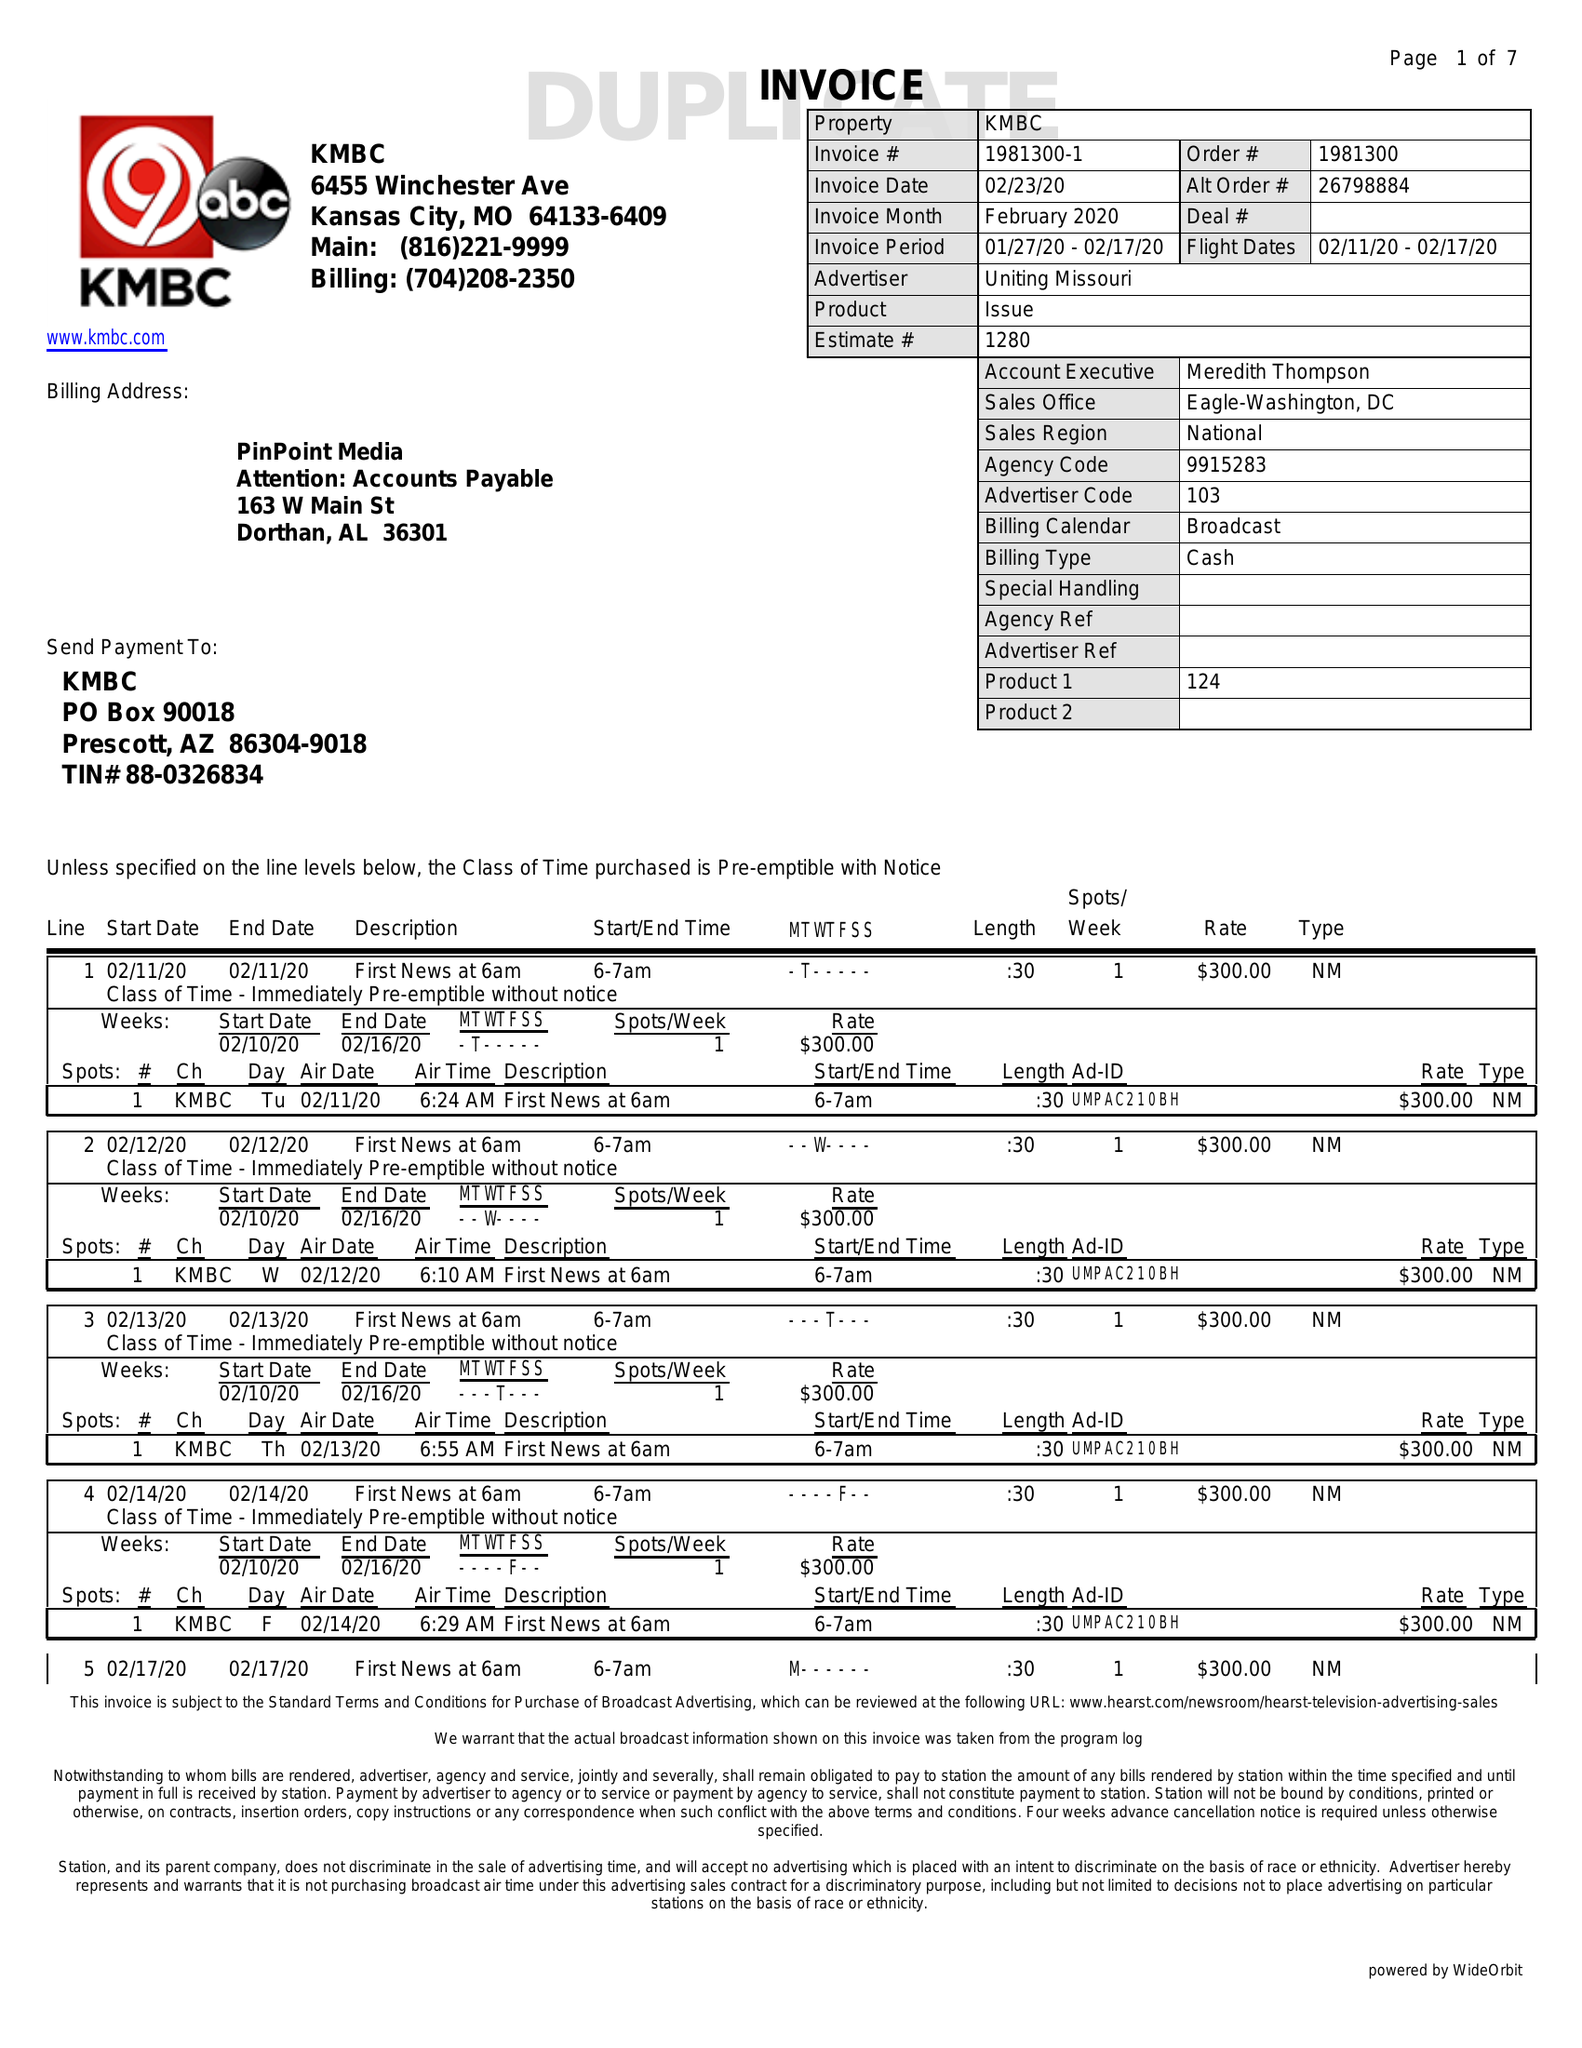What is the value for the advertiser?
Answer the question using a single word or phrase. UNITING MISSOURI 